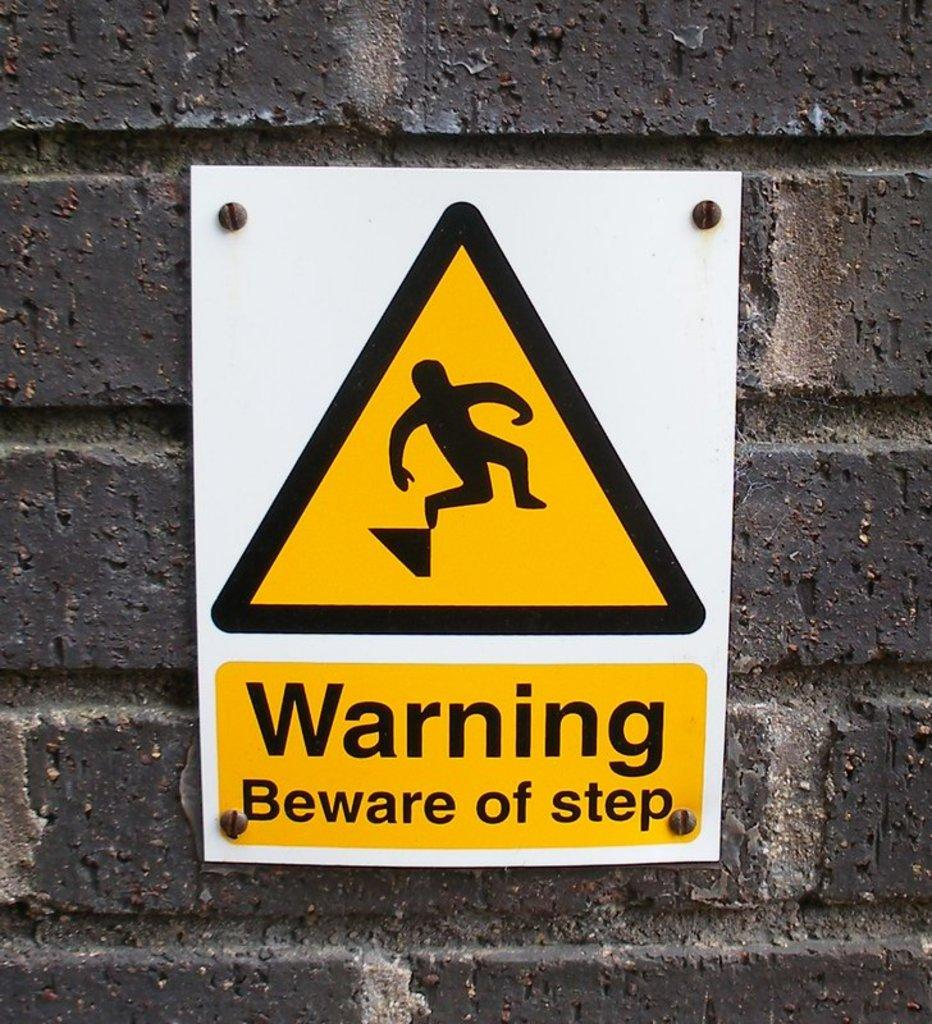<image>
Create a compact narrative representing the image presented. a sign that has the word warning on it 